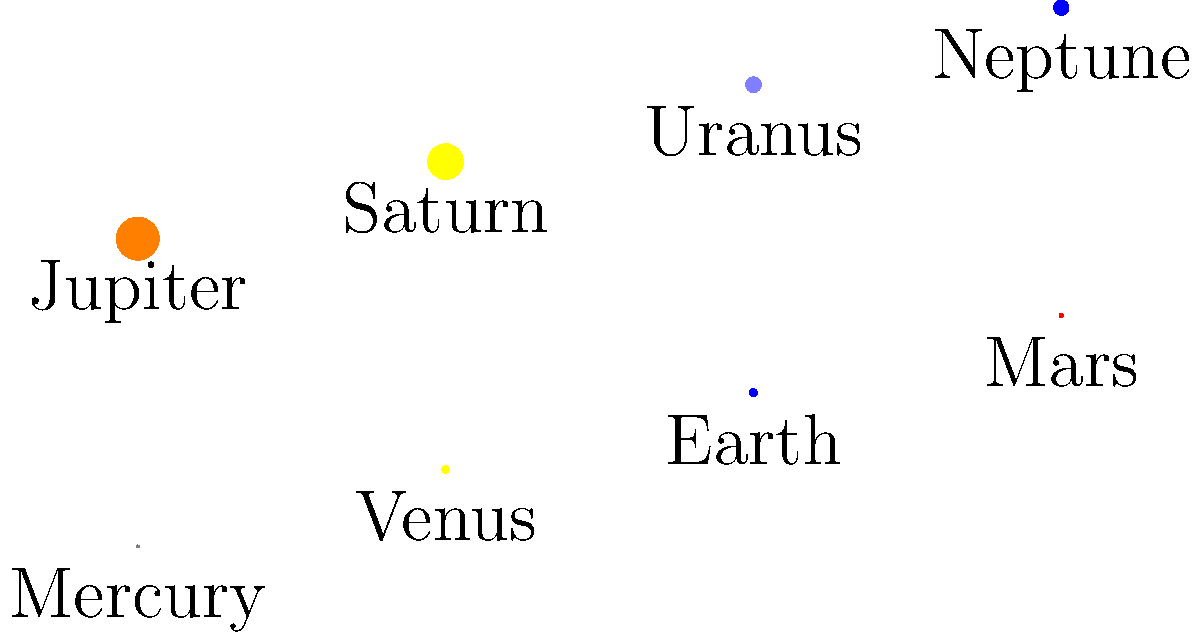As a theoretical physicist analyzing planetary data for a science journalism piece, you encounter the image above showing scaled representations of planets in our solar system. If Jupiter's radius is approximately 69,911 km, what would be the approximate radius of Earth based on this visual comparison? To solve this problem, we need to follow these steps:

1. Identify the relative sizes of Jupiter and Earth in the image.
   Jupiter's radius: 3.5 units
   Earth's radius: 0.63 units

2. Set up a proportion to relate the scaled sizes to the actual sizes:
   $\frac{\text{Jupiter's scaled radius}}{\text{Earth's scaled radius}} = \frac{\text{Jupiter's actual radius}}{\text{Earth's actual radius}}$

3. Substitute the known values:
   $\frac{3.5}{0.63} = \frac{69,911}{\text{Earth's radius}}$

4. Cross multiply:
   $3.5 \times \text{Earth's radius} = 0.63 \times 69,911$

5. Solve for Earth's radius:
   $\text{Earth's radius} = \frac{0.63 \times 69,911}{3.5}$

6. Calculate the result:
   $\text{Earth's radius} \approx 12,584$ km

This calculation provides an approximation of Earth's radius based on the scaled representation in the image and the given radius of Jupiter.
Answer: Approximately 12,584 km 